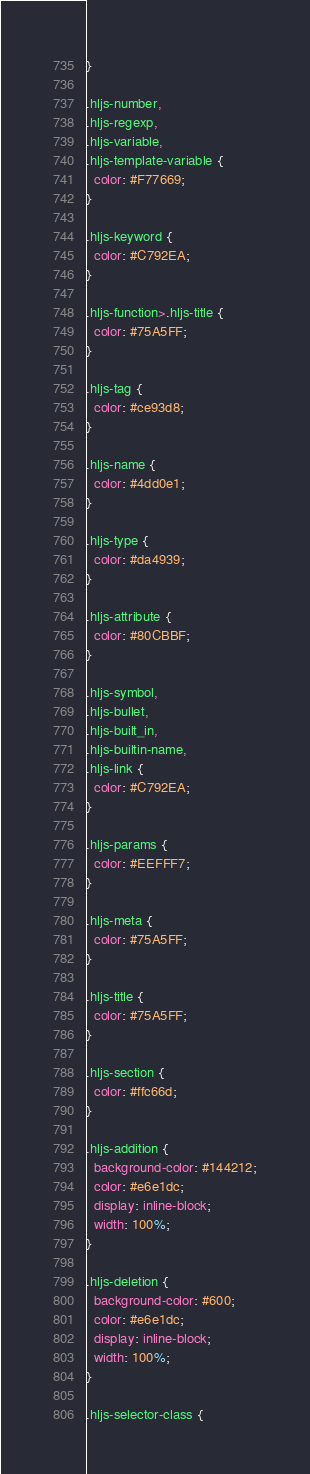Convert code to text. <code><loc_0><loc_0><loc_500><loc_500><_CSS_>}

.hljs-number,
.hljs-regexp,
.hljs-variable,
.hljs-template-variable {
  color: #F77669;
}

.hljs-keyword {
  color: #C792EA;
}

.hljs-function>.hljs-title {
  color: #75A5FF;
}

.hljs-tag {
  color: #ce93d8;
}

.hljs-name {
  color: #4dd0e1;
}

.hljs-type {
  color: #da4939;
}

.hljs-attribute {
  color: #80CBBF;
}

.hljs-symbol,
.hljs-bullet,
.hljs-built_in,
.hljs-builtin-name,
.hljs-link {
  color: #C792EA;
}

.hljs-params {
  color: #EEFFF7;
}

.hljs-meta {
  color: #75A5FF;
}

.hljs-title {
  color: #75A5FF;
}

.hljs-section {
  color: #ffc66d;
}

.hljs-addition {
  background-color: #144212;
  color: #e6e1dc;
  display: inline-block;
  width: 100%;
}

.hljs-deletion {
  background-color: #600;
  color: #e6e1dc;
  display: inline-block;
  width: 100%;
}

.hljs-selector-class {</code> 